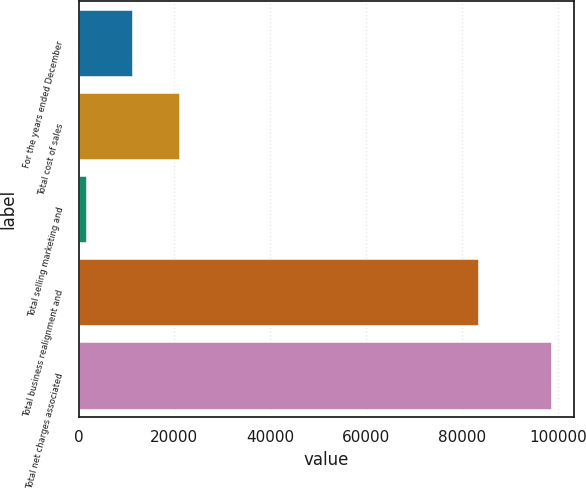Convert chart to OTSL. <chart><loc_0><loc_0><loc_500><loc_500><bar_chart><fcel>For the years ended December<fcel>Total cost of sales<fcel>Total selling marketing and<fcel>Total business realignment and<fcel>Total net charges associated<nl><fcel>11200.7<fcel>20908.4<fcel>1493<fcel>83433<fcel>98570<nl></chart> 